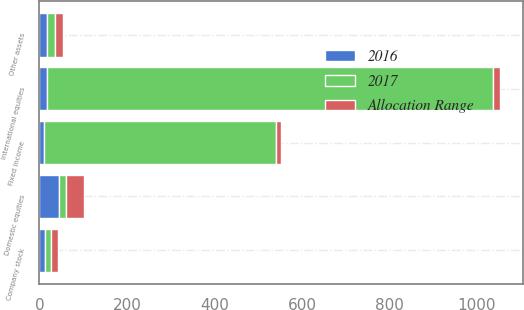Convert chart. <chart><loc_0><loc_0><loc_500><loc_500><stacked_bar_chart><ecel><fcel>Domestic equities<fcel>International equities<fcel>Fixed income<fcel>Company stock<fcel>Other assets<nl><fcel>2017<fcel>16.85<fcel>1020<fcel>530<fcel>15<fcel>20<nl><fcel>2016<fcel>43.9<fcel>17.2<fcel>10.6<fcel>11.8<fcel>16.5<nl><fcel>Allocation Range<fcel>40.5<fcel>15.5<fcel>11.2<fcel>15.1<fcel>17.7<nl></chart> 